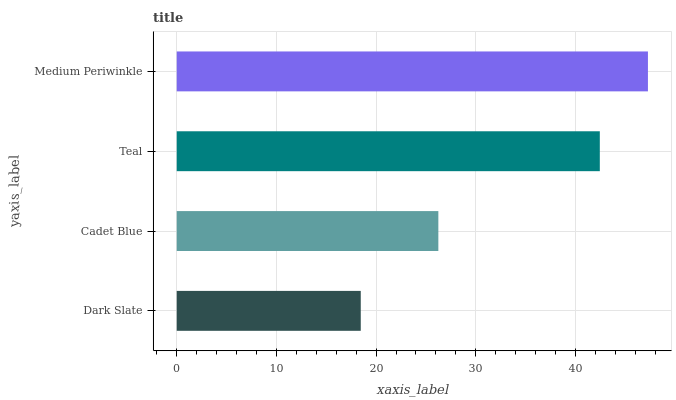Is Dark Slate the minimum?
Answer yes or no. Yes. Is Medium Periwinkle the maximum?
Answer yes or no. Yes. Is Cadet Blue the minimum?
Answer yes or no. No. Is Cadet Blue the maximum?
Answer yes or no. No. Is Cadet Blue greater than Dark Slate?
Answer yes or no. Yes. Is Dark Slate less than Cadet Blue?
Answer yes or no. Yes. Is Dark Slate greater than Cadet Blue?
Answer yes or no. No. Is Cadet Blue less than Dark Slate?
Answer yes or no. No. Is Teal the high median?
Answer yes or no. Yes. Is Cadet Blue the low median?
Answer yes or no. Yes. Is Dark Slate the high median?
Answer yes or no. No. Is Teal the low median?
Answer yes or no. No. 